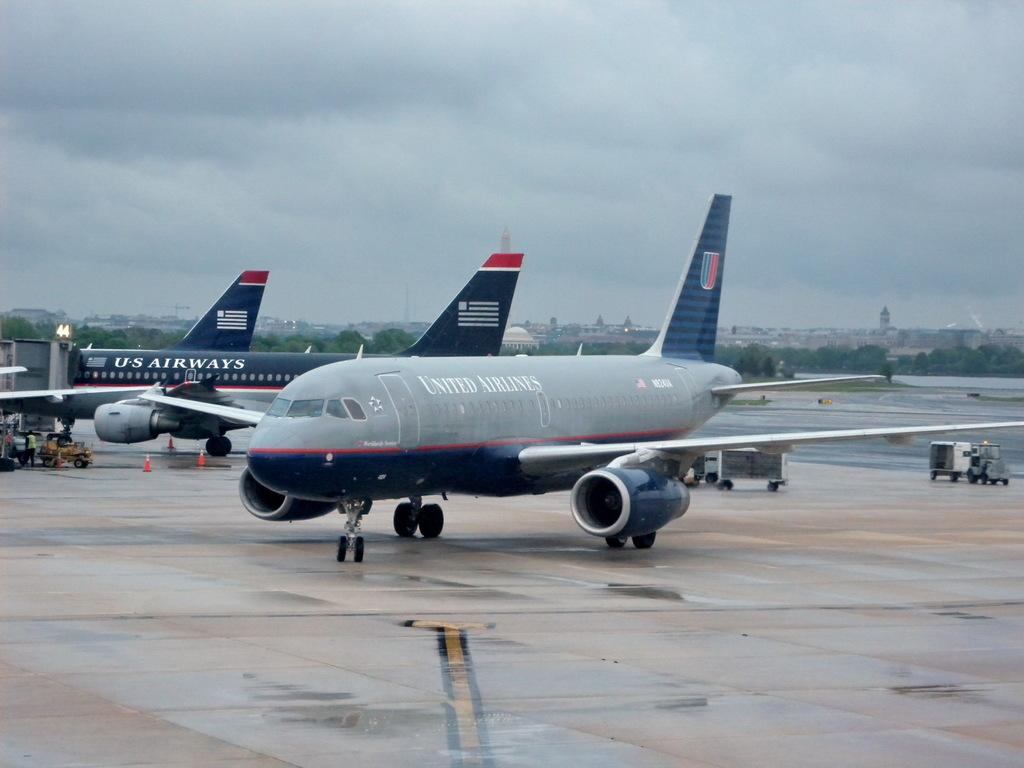<image>
Present a compact description of the photo's key features. A United Airlines jet taxis on a rainy section of tarmac. 